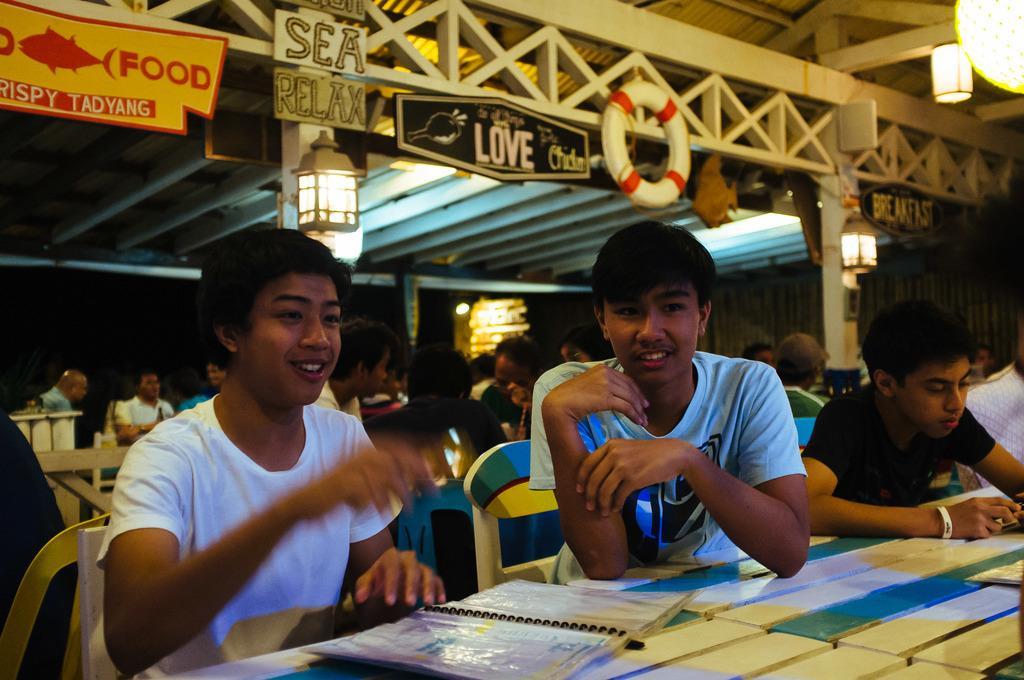Please provide a concise description of this image. here we can see few persons sitting on the chairs in front of a table and on the table we can see a spiral book. On the background we can see tube, lanterns , boards. 